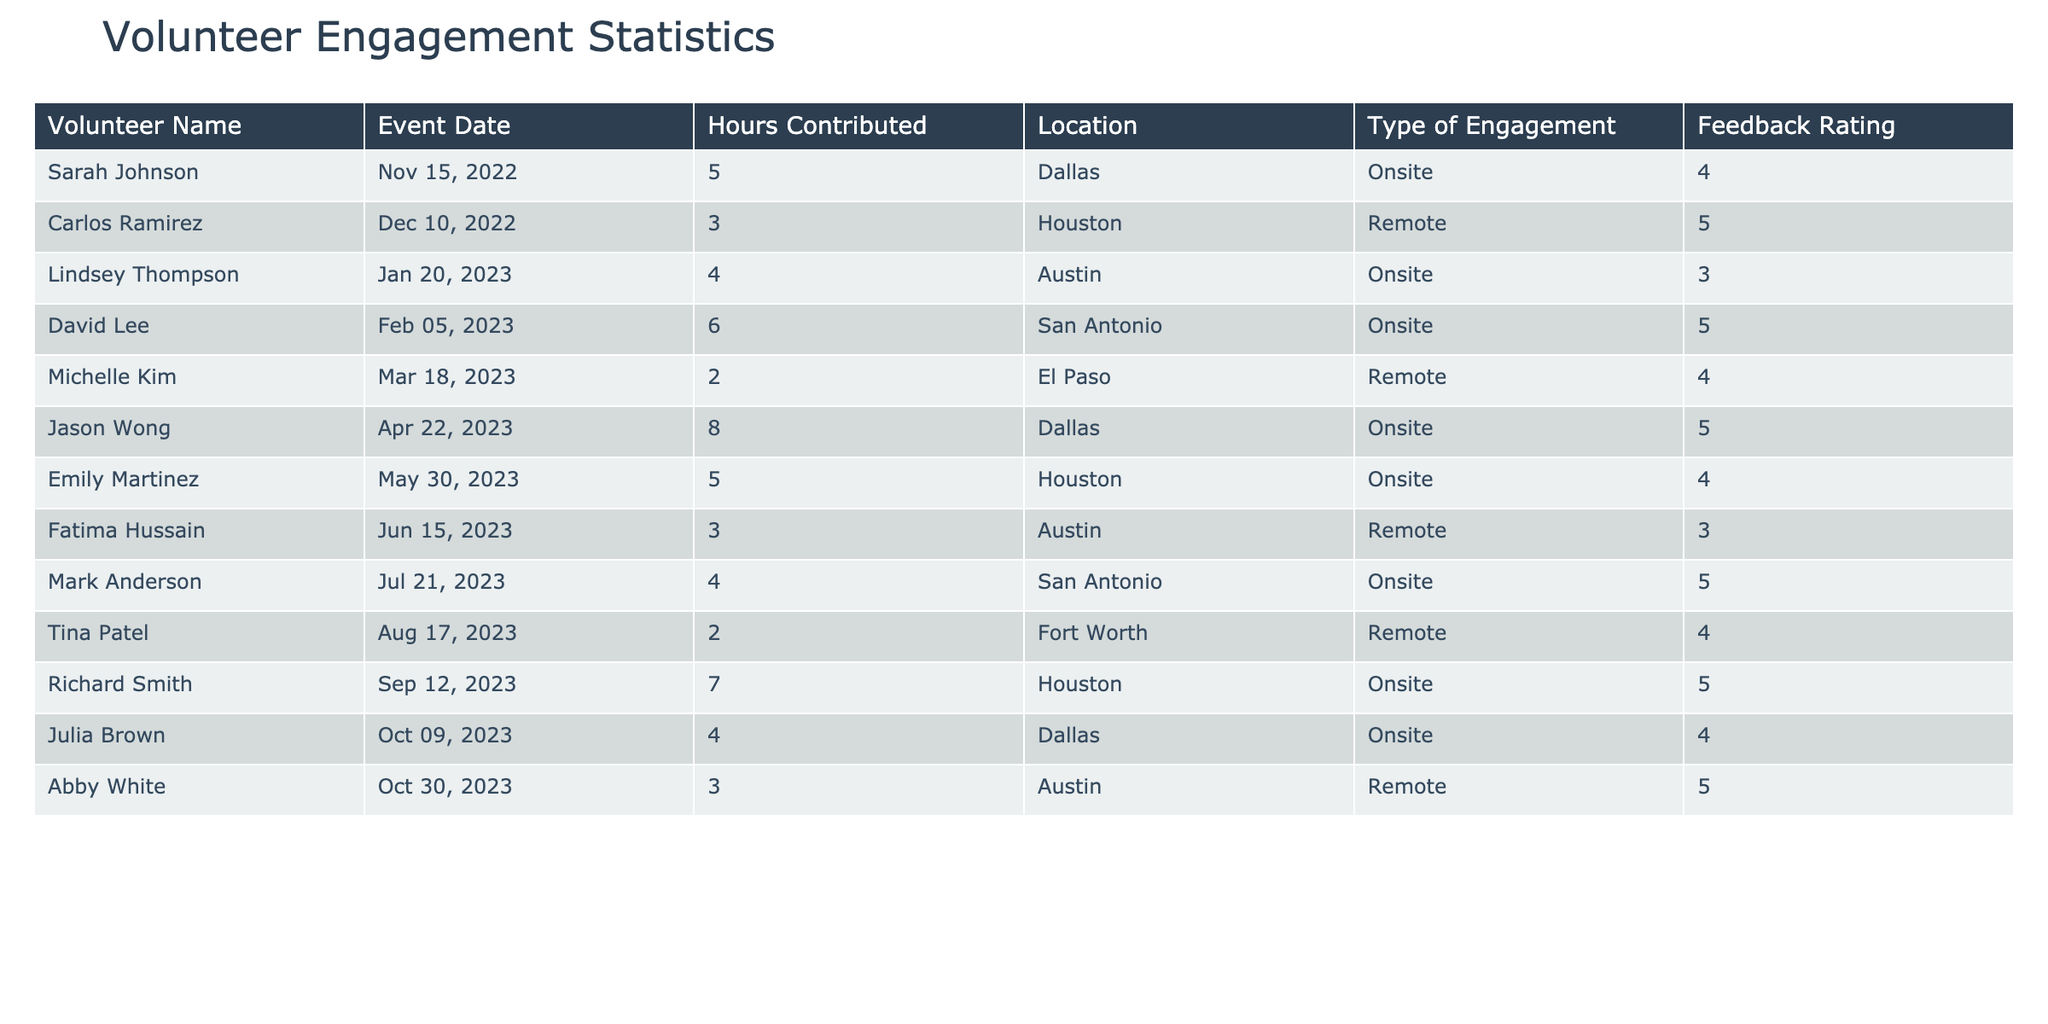What is the total number of hours contributed by volunteers? To find the total hours contributed, I need to sum the 'Hours Contributed' column: 5 + 3 + 4 + 6 + 2 + 8 + 5 + 3 + 4 + 2 + 7 + 4 + 3 = 56.
Answer: 56 Which volunteer received the highest feedback rating? By examining the 'Feedback Rating' column, I see that Carlos Ramirez and Jason Wong both received a rating of 5. They are tied for the highest rating.
Answer: Carlos Ramirez and Jason Wong How many events were held onsite compared to remote? Count the 'Type of Engagement' entries: Onsite (8) and Remote (5). There were more onsite events.
Answer: 8 onsite, 5 remote What is the average feedback rating of all volunteers? I sum the feedback ratings (4 + 5 + 3 + 5 + 4 + 5 + 4 + 3 + 5 + 4 + 5 + 4 + 5 = 54) and divide by the total number of ratings (13): 54 / 13 ≈ 4.15.
Answer: Approximately 4.15 Which location had the highest contribution of hours? Summing hours by location: Dallas (5+8+4=17), Houston (3+5+7=15), Austin (4+3=7), San Antonio (6+4=10), El Paso (2=2), and Fort Worth (2=2). Dallas has the most hours.
Answer: Dallas Did any volunteers provide a feedback rating of 3? Scanning the feedback ratings, I see Lindsey Thompson, Fatima Hussain, and Abby White all rated a 3.
Answer: Yes What is the total number of volunteers who engaged remotely? Counting the 'Type of Engagement' entries labeled as Remote: Carlos Ramirez, Michelle Kim, Fatima Hussain, Tina Patel, and Abby White gives a total of 5.
Answer: 5 Which month had the highest average hours contributed by volunteers? Calculating average hours for each month: November (5 hours, 1 volunteer), December (3 hours, 1 volunteer), January (4 hours, 1 volunteer), February (6 hours, 1 volunteer), March (2 hours, 1 volunteer), April (8 hours, 1 volunteer), May (5 hours, 1 volunteer), June (3 hours, 1 volunteer), July (4 hours, 1 volunteer), August (2 hours, 1 volunteer), September (7 hours, 1 volunteer), October (3 hours, 1 volunteer). April had the highest average of 8 hours.
Answer: April Identify the number of volunteers who provided a rating of 4 or higher. Looking at the ratings: There are 10 volunteers with feedback ratings of either 4 (5 volunteers) or 5 (5 volunteers).
Answer: 10 volunteers 